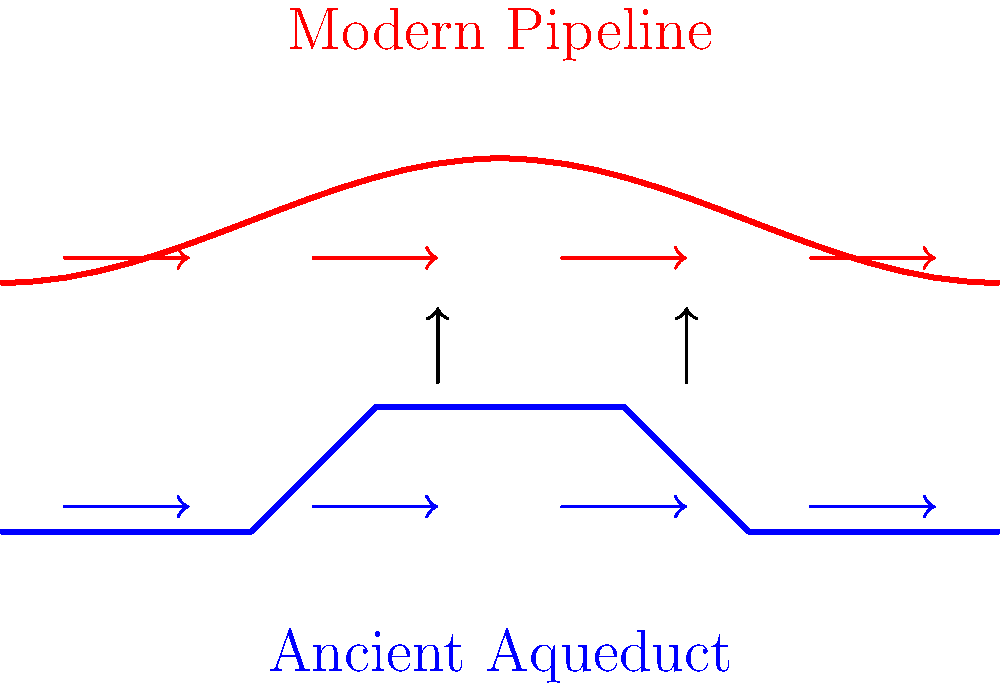Analyze the visual representation of historical aqueduct designs and their influence on modern water systems. What key principle of fluid dynamics is preserved in both ancient and modern designs, as illustrated by the arrows in the diagram? To answer this question, let's examine the diagram step-by-step:

1. The blue line represents an ancient aqueduct, showing a design with varying elevations and a generally downward slope.

2. The red line represents a modern pipeline, which has a more curved and flexible design.

3. Both designs have arrows pointing in the direction of water flow.

4. The arrows in both the ancient aqueduct and modern pipeline are consistently pointing from left to right, indicating a continuous flow direction.

5. The principle illustrated here is the conservation of flow direction. In both designs, water flows from a higher elevation to a lower elevation, utilizing gravity as the primary driving force.

6. This preservation of flow direction is crucial for efficient water transport and is a fundamental principle in fluid dynamics known as the continuity equation.

7. The continuity equation states that for an incompressible fluid in a pipe with no leaks, the volume flow rate (Q) remains constant: $Q = A_1v_1 = A_2v_2$, where A is the cross-sectional area and v is the velocity at different points in the system.

8. By maintaining a consistent flow direction, both ancient and modern designs ensure that water moves efficiently from source to destination, minimizing energy loss and maximizing the use of gravitational potential energy.

Therefore, the key principle preserved in both designs is the continuity of flow, which is fundamental to the efficient transport of water in both ancient and modern water systems.
Answer: Continuity of flow 